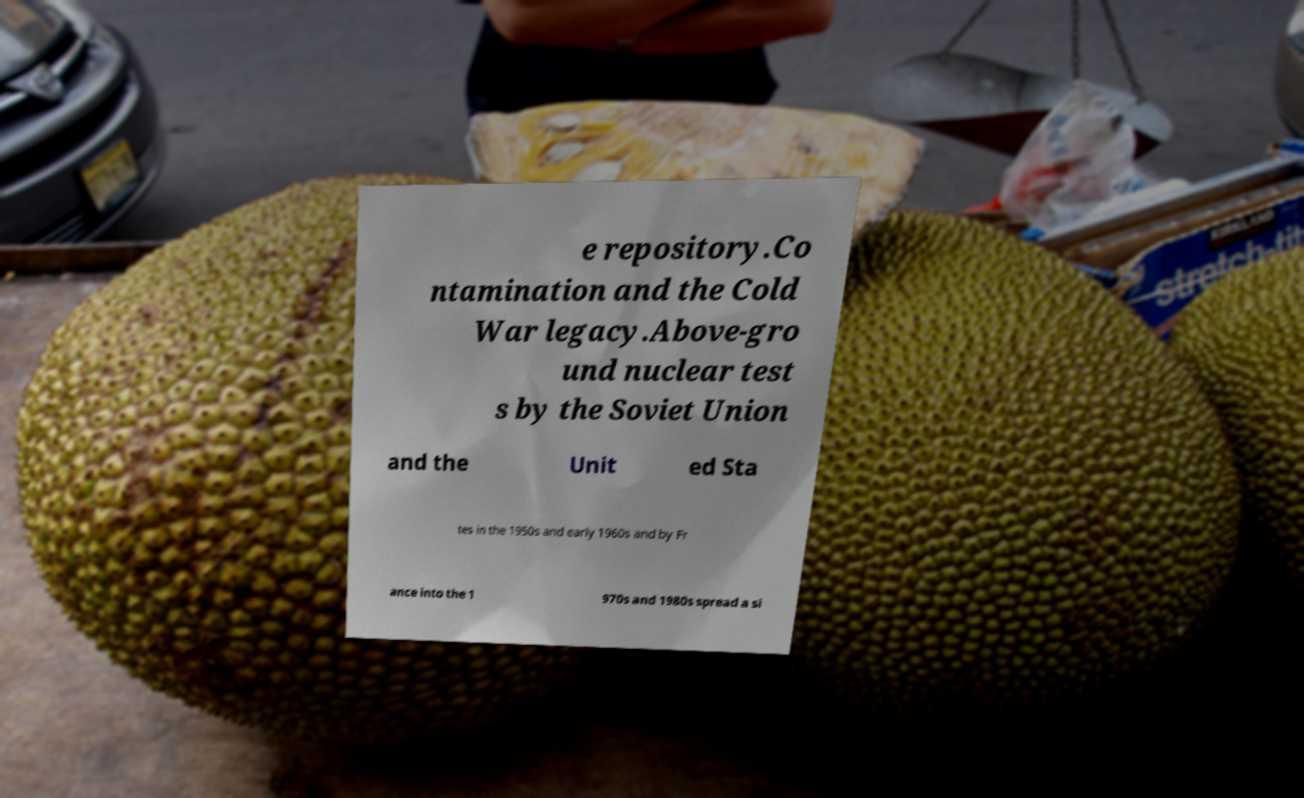There's text embedded in this image that I need extracted. Can you transcribe it verbatim? e repository.Co ntamination and the Cold War legacy.Above-gro und nuclear test s by the Soviet Union and the Unit ed Sta tes in the 1950s and early 1960s and by Fr ance into the 1 970s and 1980s spread a si 